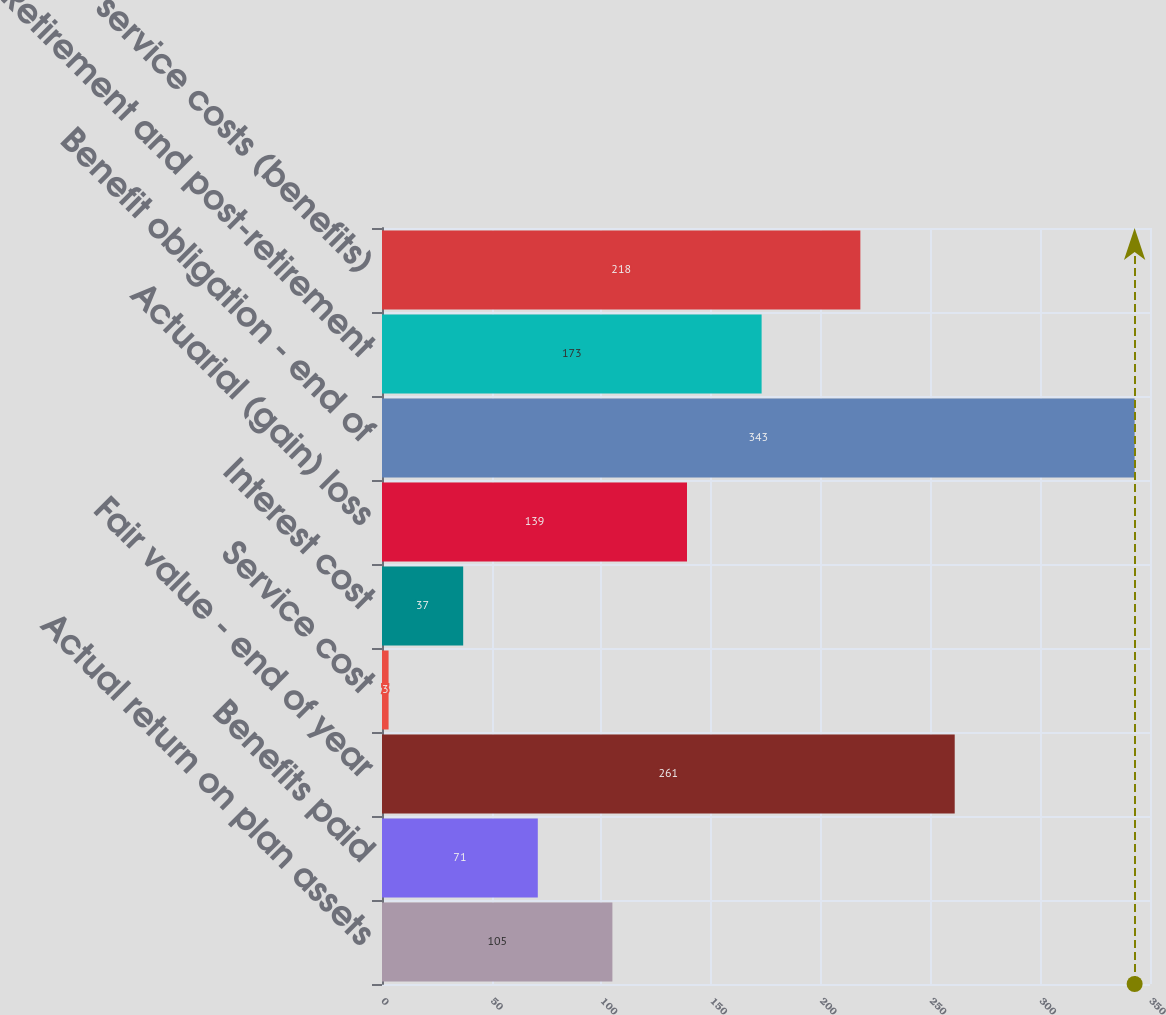Convert chart. <chart><loc_0><loc_0><loc_500><loc_500><bar_chart><fcel>Actual return on plan assets<fcel>Benefits paid<fcel>Fair value - end of year<fcel>Service cost<fcel>Interest cost<fcel>Actuarial (gain) loss<fcel>Benefit obligation - end of<fcel>Retirement and post-retirement<fcel>Prior service costs (benefits)<nl><fcel>105<fcel>71<fcel>261<fcel>3<fcel>37<fcel>139<fcel>343<fcel>173<fcel>218<nl></chart> 